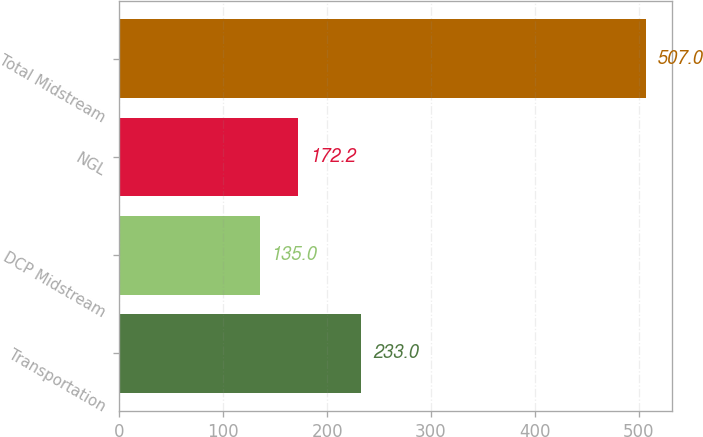Convert chart. <chart><loc_0><loc_0><loc_500><loc_500><bar_chart><fcel>Transportation<fcel>DCP Midstream<fcel>NGL<fcel>Total Midstream<nl><fcel>233<fcel>135<fcel>172.2<fcel>507<nl></chart> 